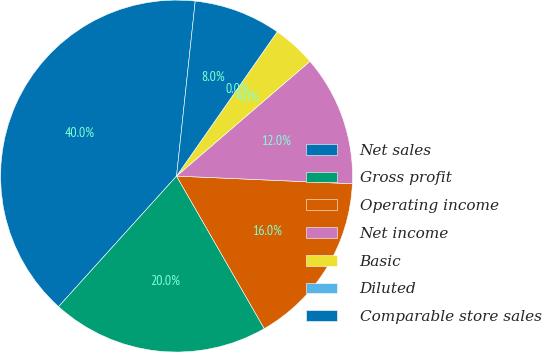<chart> <loc_0><loc_0><loc_500><loc_500><pie_chart><fcel>Net sales<fcel>Gross profit<fcel>Operating income<fcel>Net income<fcel>Basic<fcel>Diluted<fcel>Comparable store sales<nl><fcel>40.0%<fcel>20.0%<fcel>16.0%<fcel>12.0%<fcel>4.0%<fcel>0.0%<fcel>8.0%<nl></chart> 